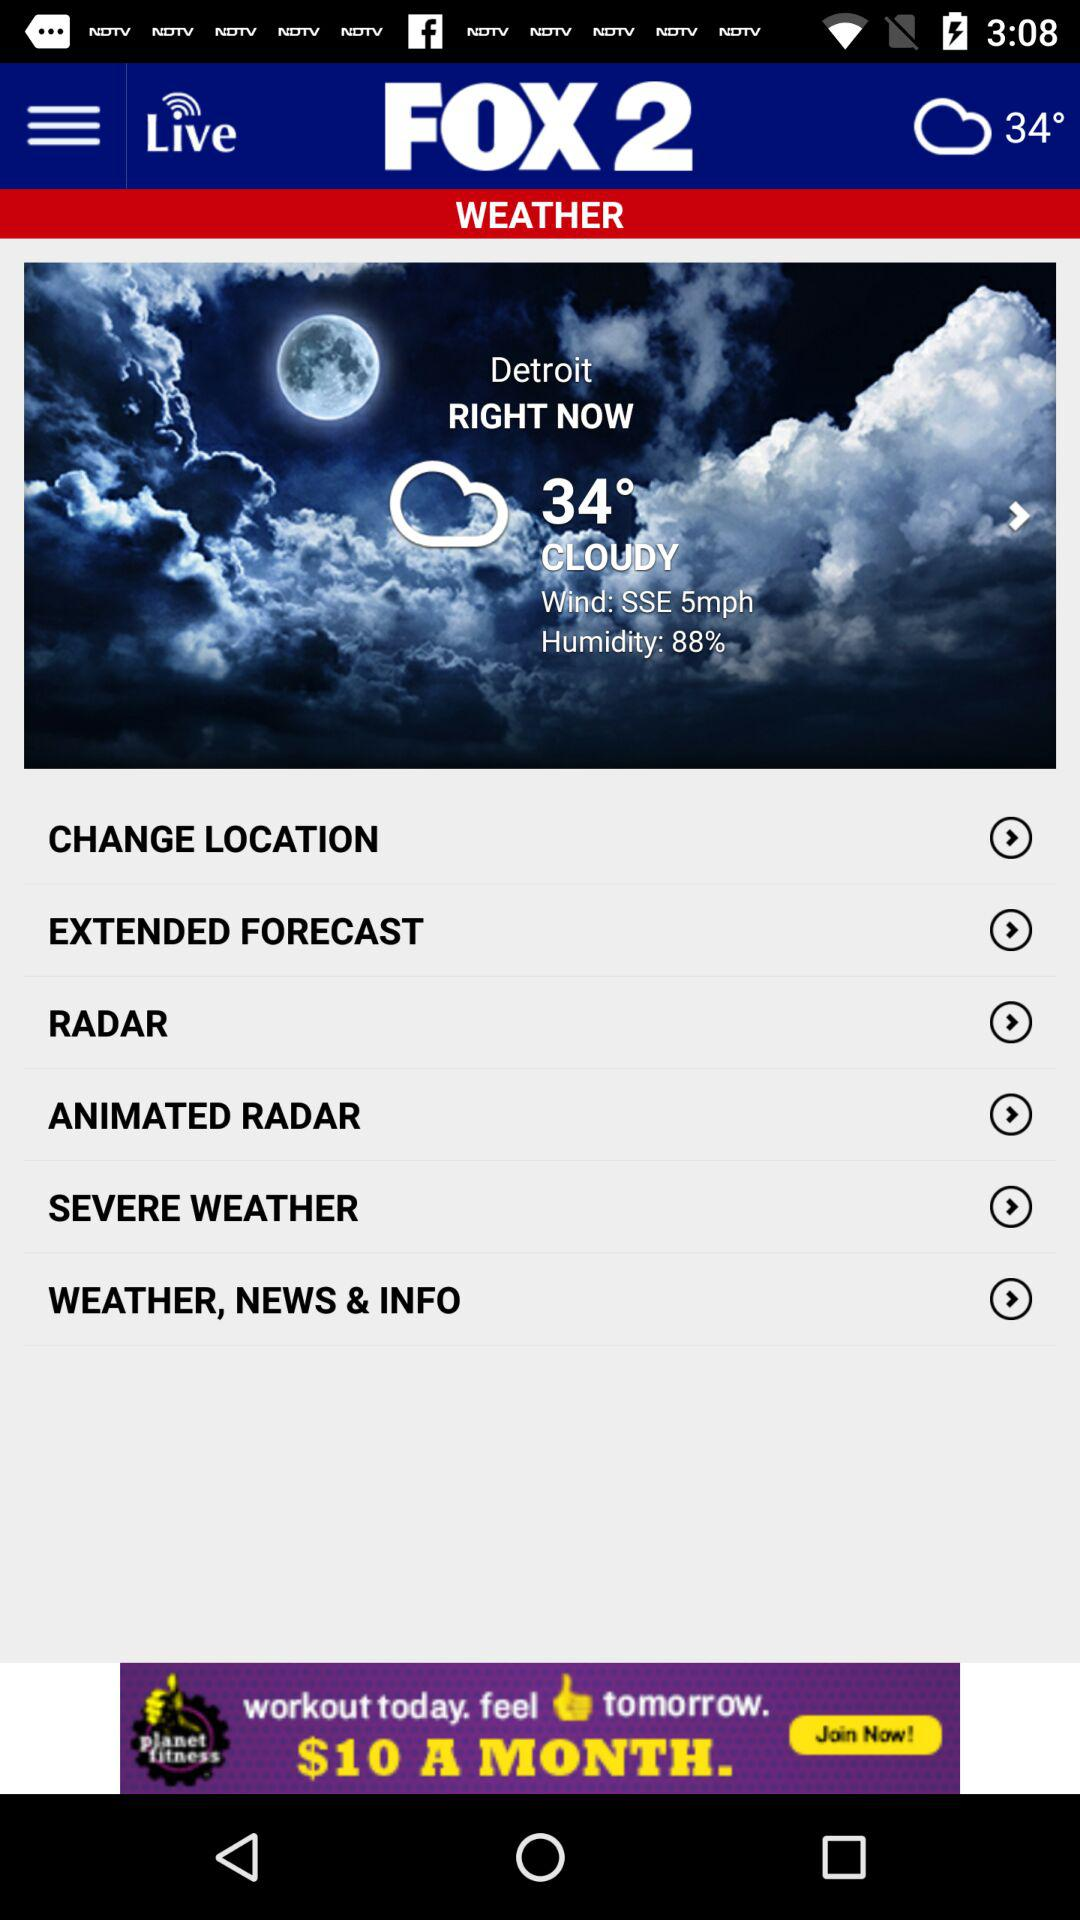Are there any signs of changing weather in the near future? The weather screenshot doesn't provide specifics about upcoming changes in weather conditions. However, options like 'EXTENDED FORECAST' and 'RADAR' on the webpage are typically used to anticipate future weather patterns. To get details on impending weather changes, one would need to navigate to those sections. 